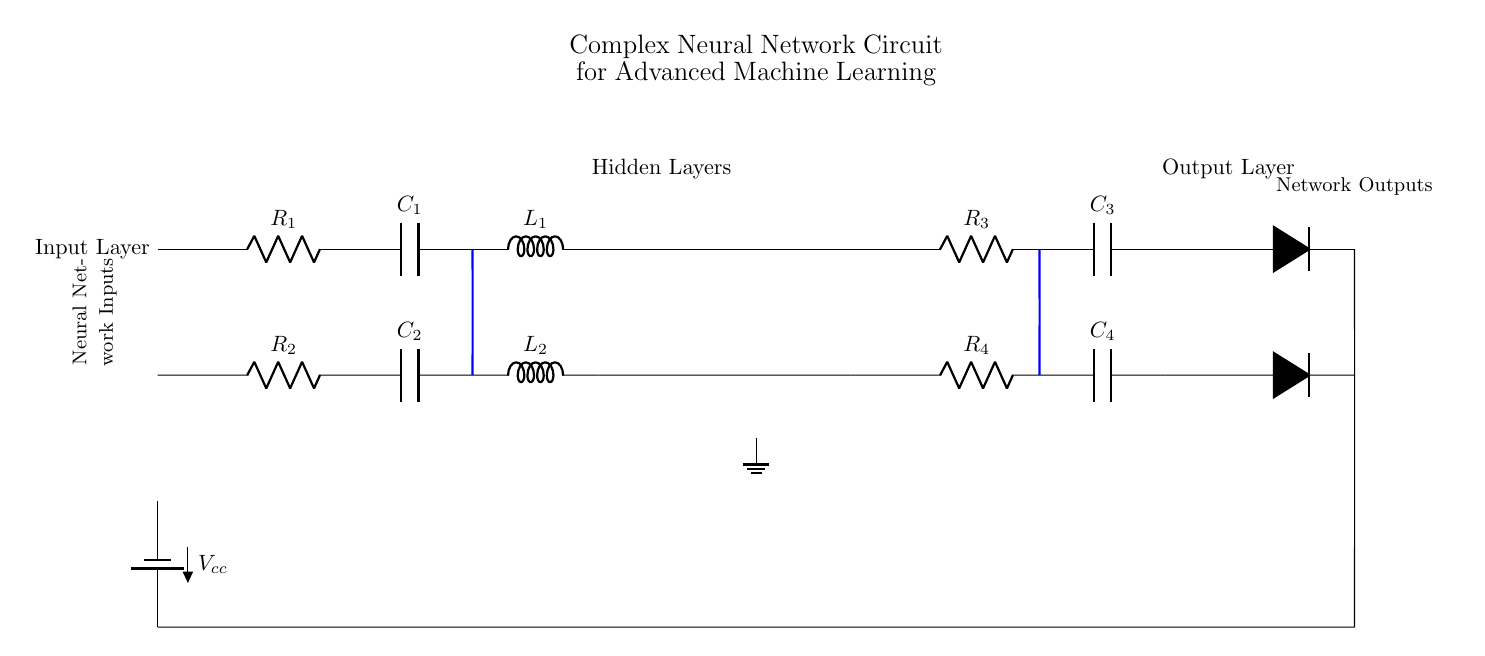What components are used in the input layer? The input layer consists of two resistors, two capacitors, and two inductors, labeled R1, C1, L1 and R2, C2, L2.
Answer: Resistors, capacitors, inductors What does the blue connection represent? The blue connection links the output of the capacitors in the input layer to each amplifier in the hidden layers, showing interconnection between different components.
Answer: Interconnects input and hidden layers How many op-amps are used in the circuit? There are two op-amps, one for each hidden layer, as indicated in the diagram.
Answer: Two What is the role of the output layer? The output layer converts processed signals from the hidden layers into output signals, shown with diodes for signal regulation.
Answer: Converts signals to outputs Which component provides power to the circuit? The circuit is powered by a battery, indicated by the battery symbol at the bottom left labeled with Vcc.
Answer: Battery What is the total resistance in the input layer? The resistance in the input layer can be determined by summing R1 and R2 since they are in series, giving a total resistance of R1 + R2.
Answer: R1 + R2 How are the components in the hidden layers connected? The components in each hidden layer are connected in series, beginning from the op-amps followed by resistors and then capacitors, forming a signal processing pathway.
Answer: Series connection 